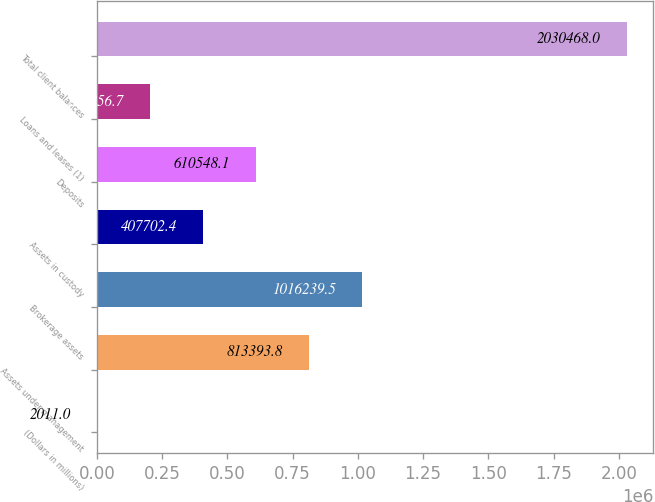<chart> <loc_0><loc_0><loc_500><loc_500><bar_chart><fcel>(Dollars in millions)<fcel>Assets under management<fcel>Brokerage assets<fcel>Assets in custody<fcel>Deposits<fcel>Loans and leases (1)<fcel>Total client balances<nl><fcel>2011<fcel>813394<fcel>1.01624e+06<fcel>407702<fcel>610548<fcel>204857<fcel>2.03047e+06<nl></chart> 